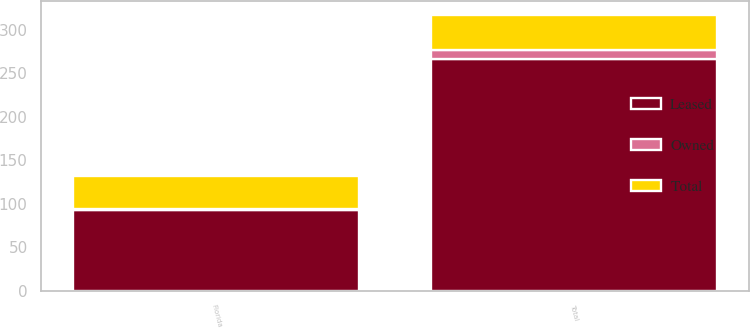Convert chart. <chart><loc_0><loc_0><loc_500><loc_500><stacked_bar_chart><ecel><fcel>Florida<fcel>Total<nl><fcel>Owned<fcel>1<fcel>11<nl><fcel>Total<fcel>38<fcel>40<nl><fcel>Leased<fcel>93<fcel>266<nl></chart> 